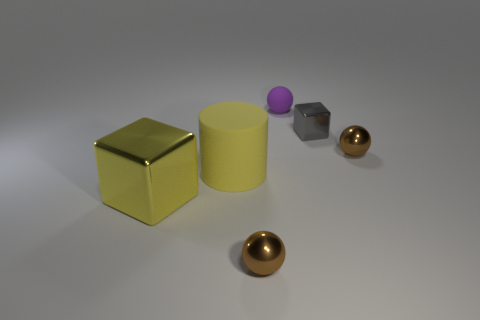Add 1 small yellow matte balls. How many objects exist? 7 Subtract all cylinders. How many objects are left? 5 Subtract 0 red balls. How many objects are left? 6 Subtract all blue rubber cubes. Subtract all big yellow objects. How many objects are left? 4 Add 5 shiny objects. How many shiny objects are left? 9 Add 5 large yellow metal things. How many large yellow metal things exist? 6 